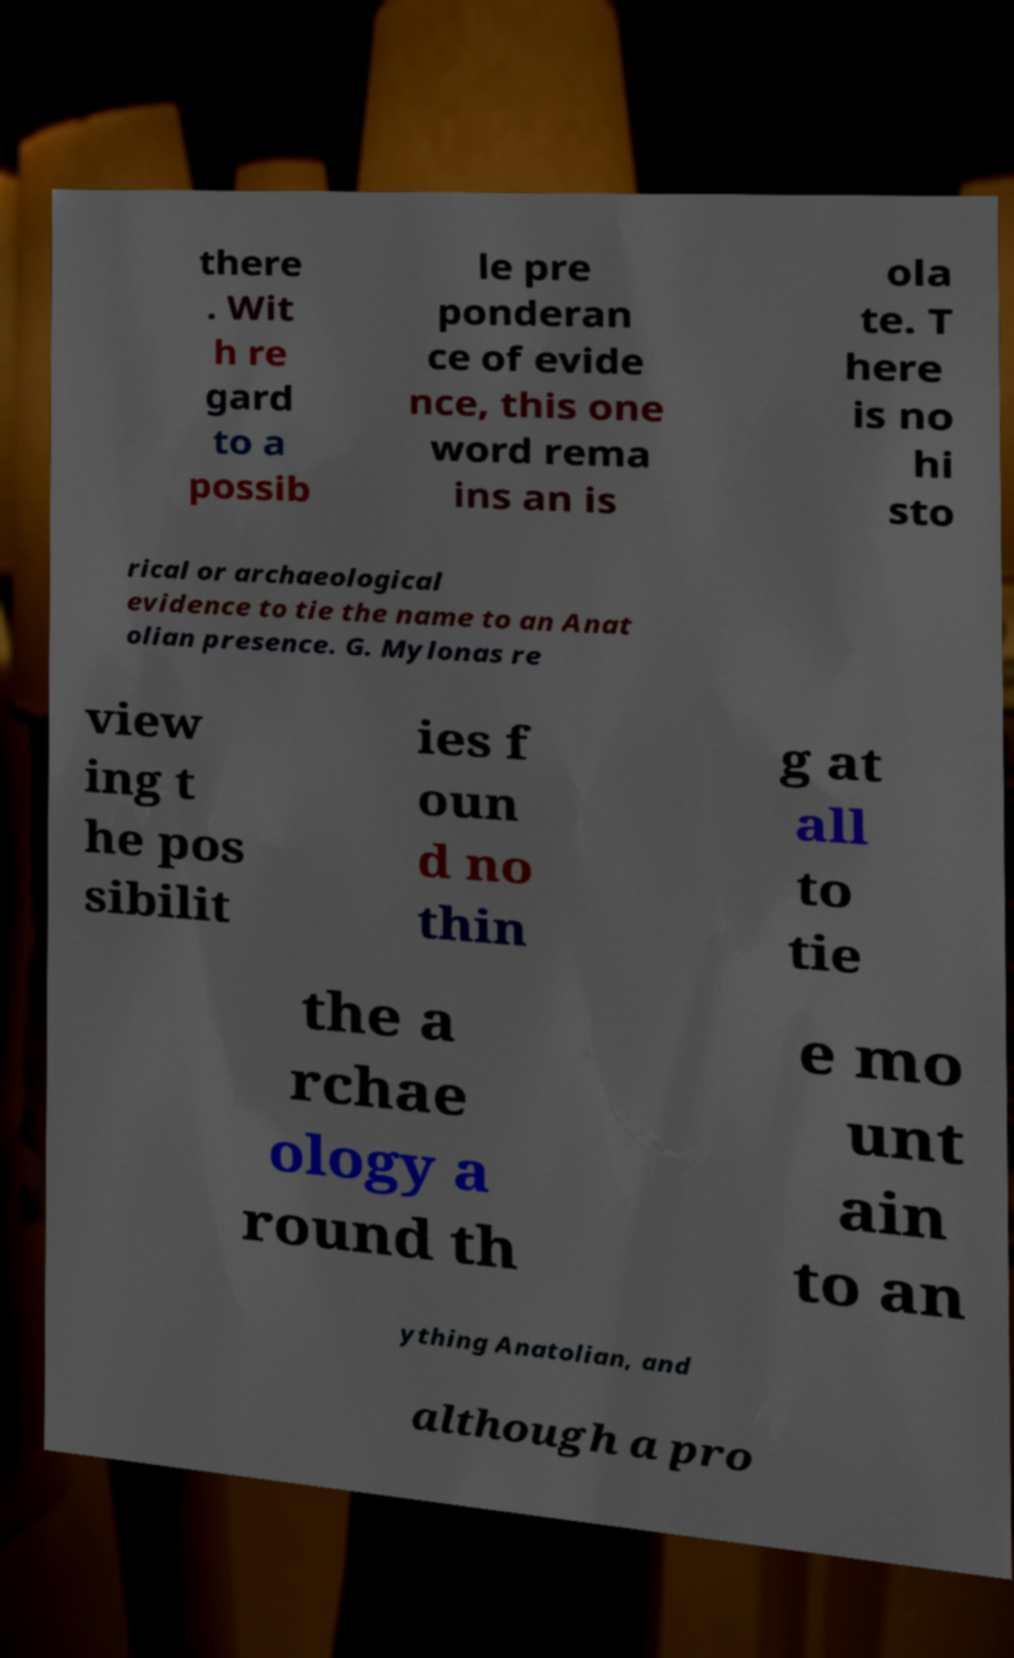Could you assist in decoding the text presented in this image and type it out clearly? there . Wit h re gard to a possib le pre ponderan ce of evide nce, this one word rema ins an is ola te. T here is no hi sto rical or archaeological evidence to tie the name to an Anat olian presence. G. Mylonas re view ing t he pos sibilit ies f oun d no thin g at all to tie the a rchae ology a round th e mo unt ain to an ything Anatolian, and although a pro 